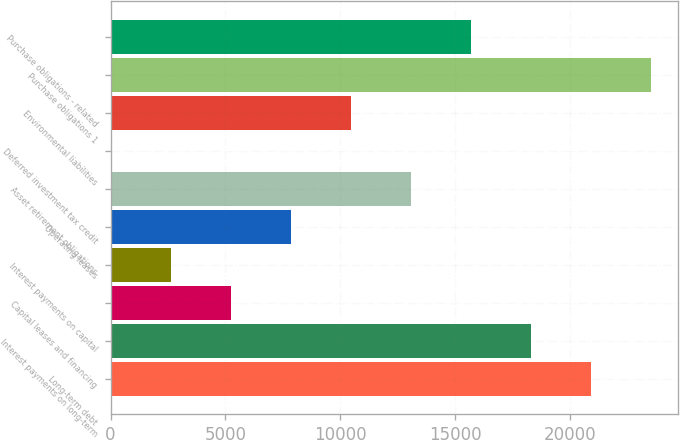<chart> <loc_0><loc_0><loc_500><loc_500><bar_chart><fcel>Long-term debt<fcel>Interest payments on long-term<fcel>Capital leases and financing<fcel>Interest payments on capital<fcel>Operating leases<fcel>Asset retirement obligations<fcel>Deferred investment tax credit<fcel>Environmental liabilities<fcel>Purchase obligations 1<fcel>Purchase obligations - related<nl><fcel>20920.8<fcel>18310.7<fcel>5260.2<fcel>2650.1<fcel>7870.3<fcel>13090.5<fcel>40<fcel>10480.4<fcel>23530.9<fcel>15700.6<nl></chart> 